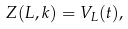<formula> <loc_0><loc_0><loc_500><loc_500>Z ( L , k ) = V _ { L } ( t ) ,</formula> 